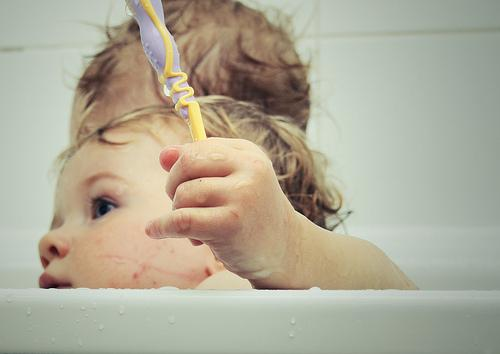Question: where are the kids?
Choices:
A. At a park.
B. Garage.
C. Treehouse.
D. Bathtub.
Answer with the letter. Answer: D Question: where was this taken?
Choices:
A. North Pole.
B. Church.
C. Backyard.
D. Bathroom.
Answer with the letter. Answer: D Question: how many children are there?
Choices:
A. 2.
B. 6.
C. 3.
D. 4.
Answer with the letter. Answer: A 